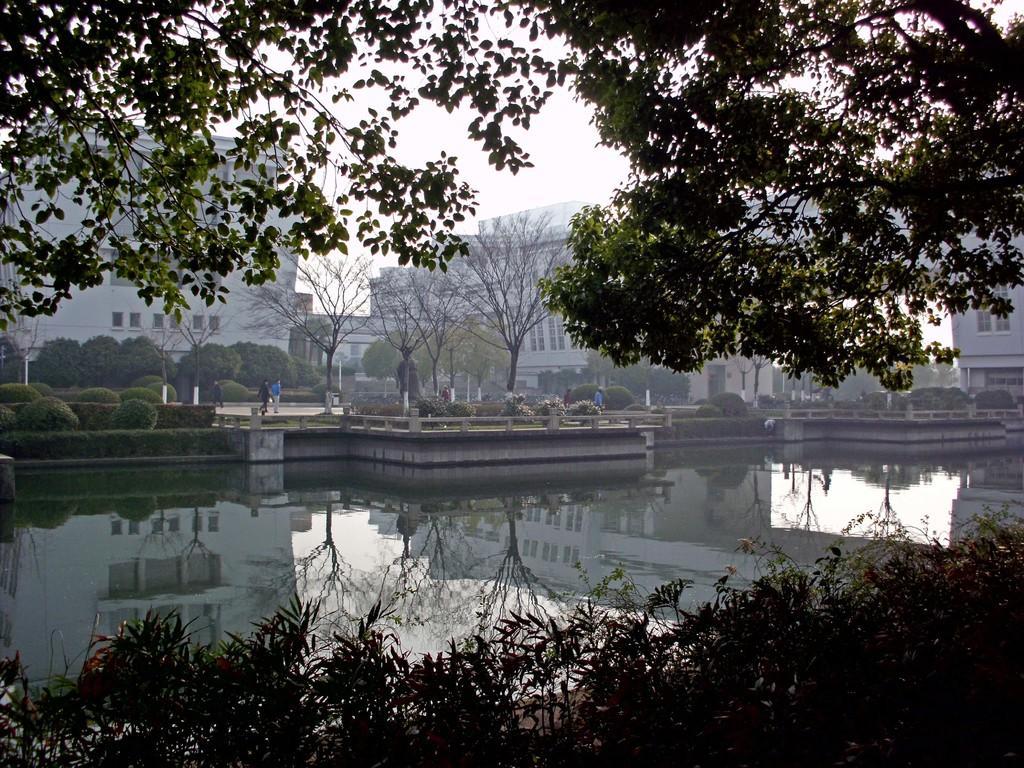Could you give a brief overview of what you see in this image? In this image there is the water. At the bottom there are the plants. Beside the water there is the ground. There are buildings, trees and hedges on the ground. There are a few people walking on the ground. At the top there is the sky. There are leaves of a tree in the image. 